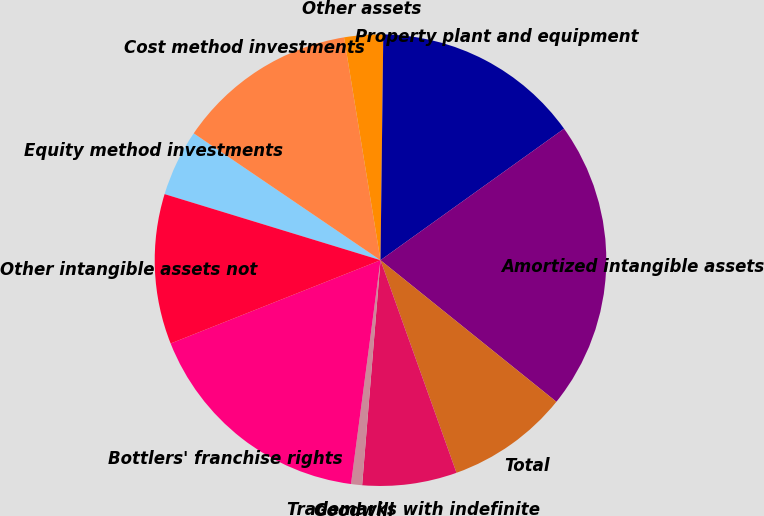Convert chart. <chart><loc_0><loc_0><loc_500><loc_500><pie_chart><fcel>Equity method investments<fcel>Cost method investments<fcel>Other assets<fcel>Property plant and equipment<fcel>Amortized intangible assets<fcel>Total<fcel>Trademarks with indefinite<fcel>Goodwill<fcel>Bottlers' franchise rights<fcel>Other intangible assets not<nl><fcel>4.77%<fcel>12.92%<fcel>2.78%<fcel>14.91%<fcel>20.68%<fcel>8.75%<fcel>6.76%<fcel>0.79%<fcel>16.9%<fcel>10.74%<nl></chart> 